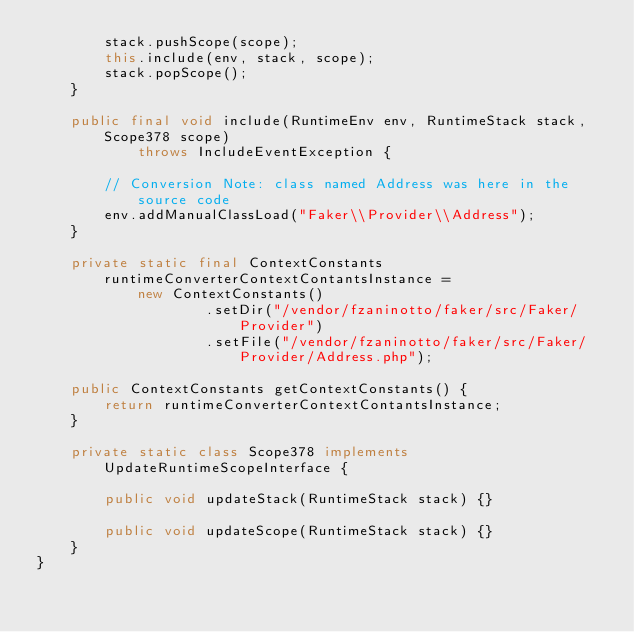Convert code to text. <code><loc_0><loc_0><loc_500><loc_500><_Java_>        stack.pushScope(scope);
        this.include(env, stack, scope);
        stack.popScope();
    }

    public final void include(RuntimeEnv env, RuntimeStack stack, Scope378 scope)
            throws IncludeEventException {

        // Conversion Note: class named Address was here in the source code
        env.addManualClassLoad("Faker\\Provider\\Address");
    }

    private static final ContextConstants runtimeConverterContextContantsInstance =
            new ContextConstants()
                    .setDir("/vendor/fzaninotto/faker/src/Faker/Provider")
                    .setFile("/vendor/fzaninotto/faker/src/Faker/Provider/Address.php");

    public ContextConstants getContextConstants() {
        return runtimeConverterContextContantsInstance;
    }

    private static class Scope378 implements UpdateRuntimeScopeInterface {

        public void updateStack(RuntimeStack stack) {}

        public void updateScope(RuntimeStack stack) {}
    }
}
</code> 